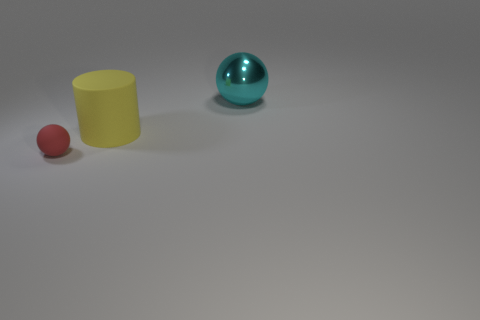Subtract 1 spheres. How many spheres are left? 1 Subtract all spheres. How many objects are left? 1 Subtract all brown cylinders. Subtract all brown spheres. How many cylinders are left? 1 Subtract all purple cylinders. How many cyan balls are left? 1 Subtract all small objects. Subtract all cyan metal spheres. How many objects are left? 1 Add 2 tiny matte balls. How many tiny matte balls are left? 3 Add 1 red objects. How many red objects exist? 2 Add 2 large shiny balls. How many objects exist? 5 Subtract 1 cyan balls. How many objects are left? 2 